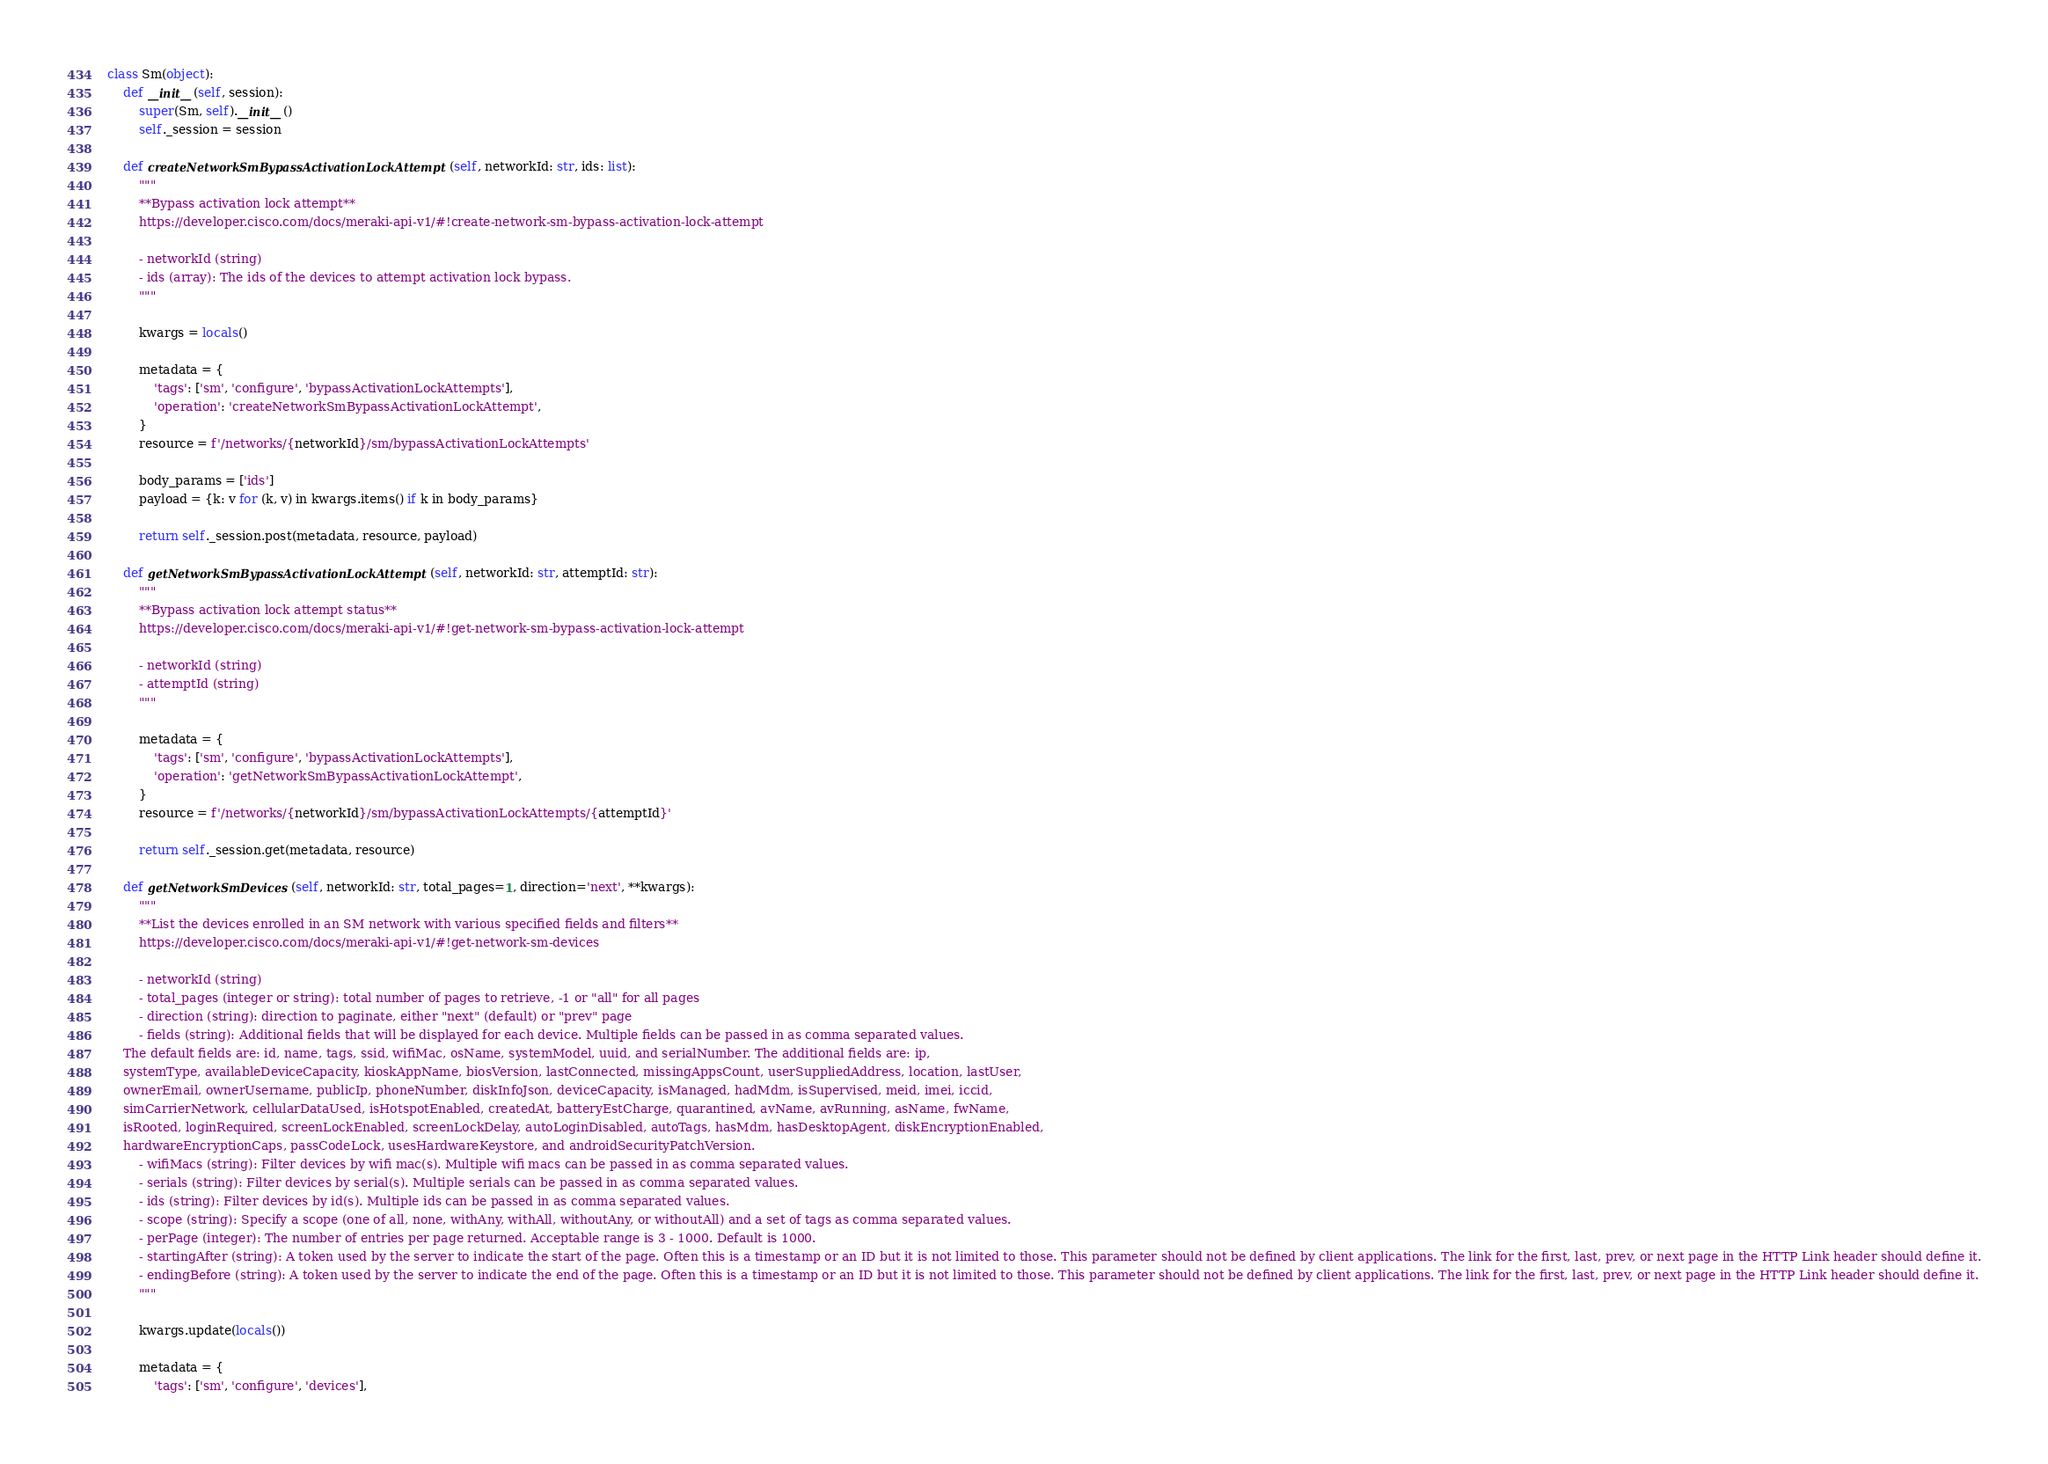<code> <loc_0><loc_0><loc_500><loc_500><_Python_>class Sm(object):
    def __init__(self, session):
        super(Sm, self).__init__()
        self._session = session

    def createNetworkSmBypassActivationLockAttempt(self, networkId: str, ids: list):
        """
        **Bypass activation lock attempt**
        https://developer.cisco.com/docs/meraki-api-v1/#!create-network-sm-bypass-activation-lock-attempt
        
        - networkId (string)
        - ids (array): The ids of the devices to attempt activation lock bypass.
        """

        kwargs = locals()

        metadata = {
            'tags': ['sm', 'configure', 'bypassActivationLockAttempts'],
            'operation': 'createNetworkSmBypassActivationLockAttempt',
        }
        resource = f'/networks/{networkId}/sm/bypassActivationLockAttempts'

        body_params = ['ids']
        payload = {k: v for (k, v) in kwargs.items() if k in body_params}

        return self._session.post(metadata, resource, payload)

    def getNetworkSmBypassActivationLockAttempt(self, networkId: str, attemptId: str):
        """
        **Bypass activation lock attempt status**
        https://developer.cisco.com/docs/meraki-api-v1/#!get-network-sm-bypass-activation-lock-attempt
        
        - networkId (string)
        - attemptId (string)
        """

        metadata = {
            'tags': ['sm', 'configure', 'bypassActivationLockAttempts'],
            'operation': 'getNetworkSmBypassActivationLockAttempt',
        }
        resource = f'/networks/{networkId}/sm/bypassActivationLockAttempts/{attemptId}'

        return self._session.get(metadata, resource)

    def getNetworkSmDevices(self, networkId: str, total_pages=1, direction='next', **kwargs):
        """
        **List the devices enrolled in an SM network with various specified fields and filters**
        https://developer.cisco.com/docs/meraki-api-v1/#!get-network-sm-devices
        
        - networkId (string)
        - total_pages (integer or string): total number of pages to retrieve, -1 or "all" for all pages
        - direction (string): direction to paginate, either "next" (default) or "prev" page
        - fields (string): Additional fields that will be displayed for each device. Multiple fields can be passed in as comma separated values.
    The default fields are: id, name, tags, ssid, wifiMac, osName, systemModel, uuid, and serialNumber. The additional fields are: ip,
    systemType, availableDeviceCapacity, kioskAppName, biosVersion, lastConnected, missingAppsCount, userSuppliedAddress, location, lastUser,
    ownerEmail, ownerUsername, publicIp, phoneNumber, diskInfoJson, deviceCapacity, isManaged, hadMdm, isSupervised, meid, imei, iccid,
    simCarrierNetwork, cellularDataUsed, isHotspotEnabled, createdAt, batteryEstCharge, quarantined, avName, avRunning, asName, fwName,
    isRooted, loginRequired, screenLockEnabled, screenLockDelay, autoLoginDisabled, autoTags, hasMdm, hasDesktopAgent, diskEncryptionEnabled,
    hardwareEncryptionCaps, passCodeLock, usesHardwareKeystore, and androidSecurityPatchVersion.
        - wifiMacs (string): Filter devices by wifi mac(s). Multiple wifi macs can be passed in as comma separated values.
        - serials (string): Filter devices by serial(s). Multiple serials can be passed in as comma separated values.
        - ids (string): Filter devices by id(s). Multiple ids can be passed in as comma separated values.
        - scope (string): Specify a scope (one of all, none, withAny, withAll, withoutAny, or withoutAll) and a set of tags as comma separated values.
        - perPage (integer): The number of entries per page returned. Acceptable range is 3 - 1000. Default is 1000.
        - startingAfter (string): A token used by the server to indicate the start of the page. Often this is a timestamp or an ID but it is not limited to those. This parameter should not be defined by client applications. The link for the first, last, prev, or next page in the HTTP Link header should define it.
        - endingBefore (string): A token used by the server to indicate the end of the page. Often this is a timestamp or an ID but it is not limited to those. This parameter should not be defined by client applications. The link for the first, last, prev, or next page in the HTTP Link header should define it.
        """

        kwargs.update(locals())

        metadata = {
            'tags': ['sm', 'configure', 'devices'],</code> 